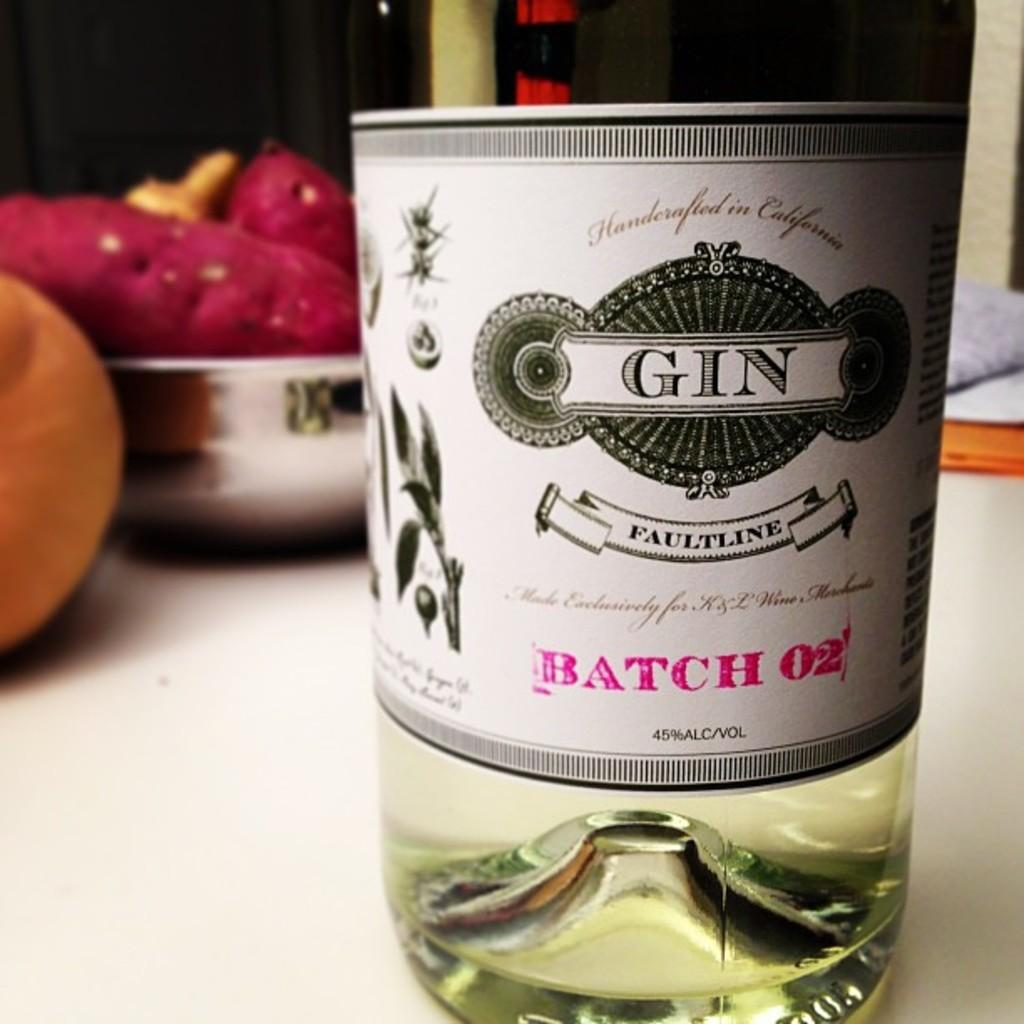What is on the bottle that is visible in the image? There is a sticker on the bottle in the image. What else can be seen on the table in the image? There is a bowl in the image. What type of food is present on the table in the image? The food on the table in the image is not specified, but it is clear that there is food present. What riddle is written on the sticker of the bottle in the image? There is no riddle written on the sticker of the bottle in the image; it only has a sticker. How does the bowl blow air in the image? The bowl does not blow air in the image; it is a stationary object. 